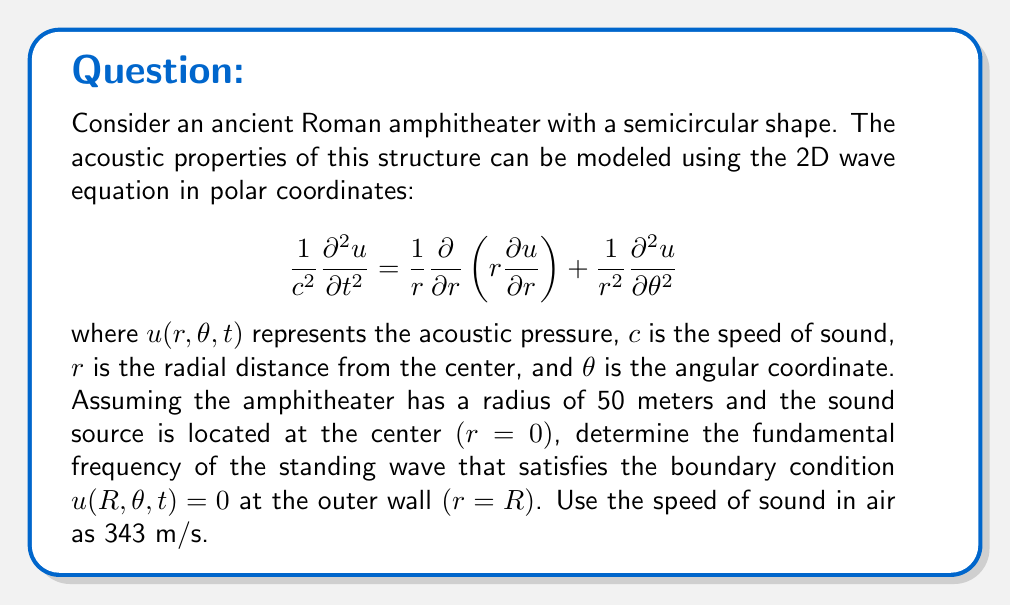Provide a solution to this math problem. To solve this problem, we need to use the method of separation of variables and apply the given boundary conditions. Let's follow these steps:

1) Assume a solution of the form: $u(r,\theta,t) = R(r)\Theta(\theta)T(t)$

2) Substituting this into the wave equation and separating variables, we get three ordinary differential equations:

   For $T(t)$: $\frac{d^2T}{dt^2} + \omega^2T = 0$
   For $\Theta(\theta)$: $\frac{d^2\Theta}{d\theta^2} + m^2\Theta = 0$
   For $R(r)$: $r^2\frac{d^2R}{dr^2} + r\frac{dR}{dr} + (k^2r^2 - m^2)R = 0$

   Where $k = \frac{\omega}{c}$ and $m$ is an integer.

3) The equation for $R(r)$ is the Bessel equation of order $m$. Its general solution is:

   $R(r) = AJ_m(kr) + BY_m(kr)$

   where $J_m$ and $Y_m$ are Bessel functions of the first and second kind, respectively.

4) Since the solution must be finite at $r=0$, and $Y_m$ is singular at $r=0$, we must have $B=0$. Thus:

   $R(r) = AJ_m(kr)$

5) Applying the boundary condition $u(R,\theta,t) = 0$, we get:

   $J_m(kR) = 0$

6) The smallest positive value of $kR$ that satisfies this equation (for $m=0$, as we're looking for the fundamental frequency) is the first zero of $J_0$, which is approximately 2.4048.

7) Thus: $kR = 2.4048$

8) Substituting $k = \frac{\omega}{c}$ and $\omega = 2\pi f$, we get:

   $\frac{2\pi f R}{c} = 2.4048$

9) Solving for $f$:

   $f = \frac{2.4048 c}{2\pi R}$

10) Plugging in the values $c = 343$ m/s and $R = 50$ m:

    $f = \frac{2.4048 \cdot 343}{2\pi \cdot 50} \approx 2.61$ Hz
Answer: The fundamental frequency of the standing wave in the amphitheater is approximately 2.61 Hz. 